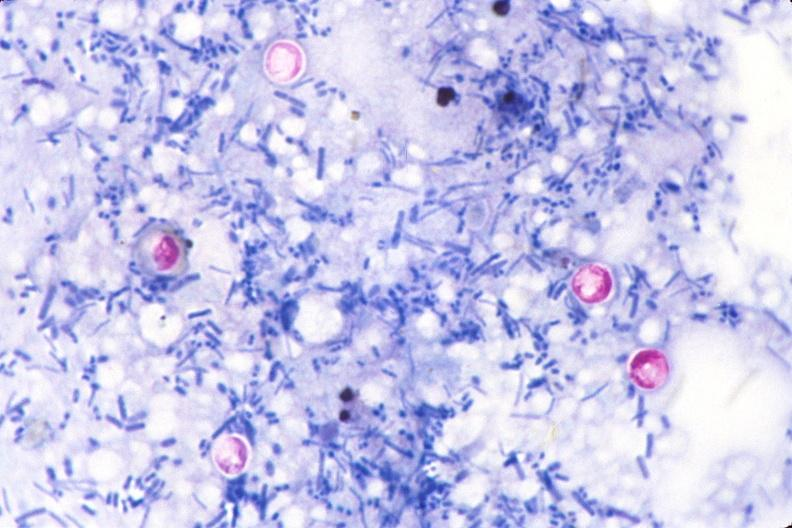does anomalous origin stain of feces?
Answer the question using a single word or phrase. No 